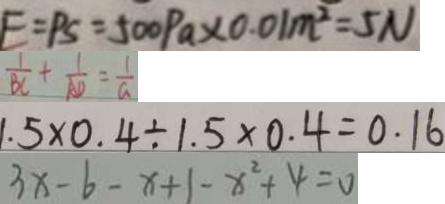Convert formula to latex. <formula><loc_0><loc_0><loc_500><loc_500>F = P S = 5 0 0 P a \times 0 . 0 1 m ^ { 2 } = 5 N 
 \frac { 1 } { B C } + \frac { 1 } { A D } = \frac { 1 } { a } 
 1 . 5 \times 0 . 4 \div 1 . 5 \times 0 . 4 = 0 . 1 6 
 3 x - b - x + 1 - x ^ { 2 } + 4 = 0</formula> 